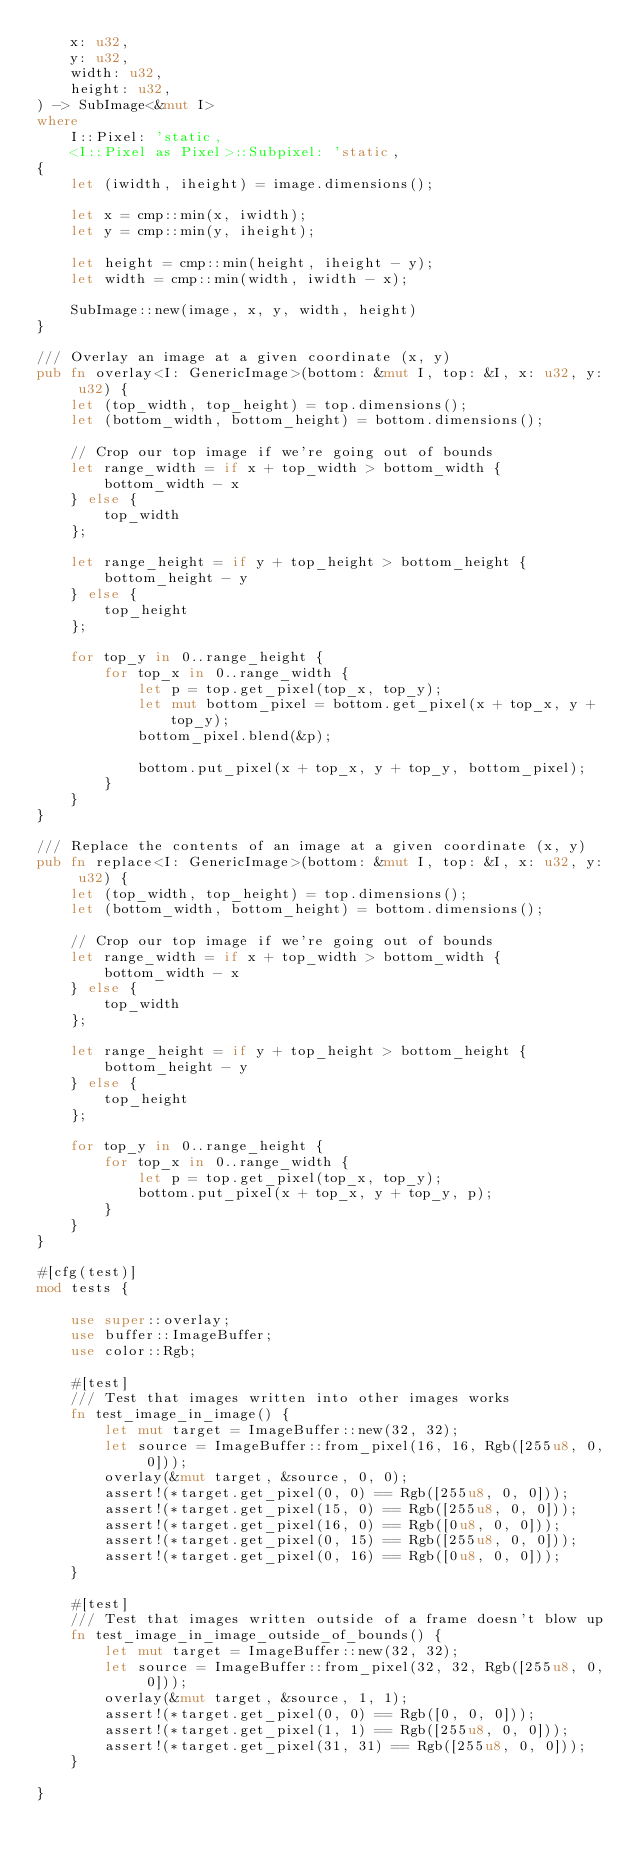<code> <loc_0><loc_0><loc_500><loc_500><_Rust_>    x: u32,
    y: u32,
    width: u32,
    height: u32,
) -> SubImage<&mut I>
where
    I::Pixel: 'static,
    <I::Pixel as Pixel>::Subpixel: 'static,
{
    let (iwidth, iheight) = image.dimensions();

    let x = cmp::min(x, iwidth);
    let y = cmp::min(y, iheight);

    let height = cmp::min(height, iheight - y);
    let width = cmp::min(width, iwidth - x);

    SubImage::new(image, x, y, width, height)
}

/// Overlay an image at a given coordinate (x, y)
pub fn overlay<I: GenericImage>(bottom: &mut I, top: &I, x: u32, y: u32) {
    let (top_width, top_height) = top.dimensions();
    let (bottom_width, bottom_height) = bottom.dimensions();

    // Crop our top image if we're going out of bounds
    let range_width = if x + top_width > bottom_width {
        bottom_width - x
    } else {
        top_width
    };

    let range_height = if y + top_height > bottom_height {
        bottom_height - y
    } else {
        top_height
    };

    for top_y in 0..range_height {
        for top_x in 0..range_width {
            let p = top.get_pixel(top_x, top_y);
            let mut bottom_pixel = bottom.get_pixel(x + top_x, y + top_y);
            bottom_pixel.blend(&p);

            bottom.put_pixel(x + top_x, y + top_y, bottom_pixel);
        }
    }
}

/// Replace the contents of an image at a given coordinate (x, y)
pub fn replace<I: GenericImage>(bottom: &mut I, top: &I, x: u32, y: u32) {
    let (top_width, top_height) = top.dimensions();
    let (bottom_width, bottom_height) = bottom.dimensions();

    // Crop our top image if we're going out of bounds
    let range_width = if x + top_width > bottom_width {
        bottom_width - x
    } else {
        top_width
    };

    let range_height = if y + top_height > bottom_height {
        bottom_height - y
    } else {
        top_height
    };

    for top_y in 0..range_height {
        for top_x in 0..range_width {
            let p = top.get_pixel(top_x, top_y);
            bottom.put_pixel(x + top_x, y + top_y, p);
        }
    }
}

#[cfg(test)]
mod tests {

    use super::overlay;
    use buffer::ImageBuffer;
    use color::Rgb;

    #[test]
    /// Test that images written into other images works
    fn test_image_in_image() {
        let mut target = ImageBuffer::new(32, 32);
        let source = ImageBuffer::from_pixel(16, 16, Rgb([255u8, 0, 0]));
        overlay(&mut target, &source, 0, 0);
        assert!(*target.get_pixel(0, 0) == Rgb([255u8, 0, 0]));
        assert!(*target.get_pixel(15, 0) == Rgb([255u8, 0, 0]));
        assert!(*target.get_pixel(16, 0) == Rgb([0u8, 0, 0]));
        assert!(*target.get_pixel(0, 15) == Rgb([255u8, 0, 0]));
        assert!(*target.get_pixel(0, 16) == Rgb([0u8, 0, 0]));
    }

    #[test]
    /// Test that images written outside of a frame doesn't blow up
    fn test_image_in_image_outside_of_bounds() {
        let mut target = ImageBuffer::new(32, 32);
        let source = ImageBuffer::from_pixel(32, 32, Rgb([255u8, 0, 0]));
        overlay(&mut target, &source, 1, 1);
        assert!(*target.get_pixel(0, 0) == Rgb([0, 0, 0]));
        assert!(*target.get_pixel(1, 1) == Rgb([255u8, 0, 0]));
        assert!(*target.get_pixel(31, 31) == Rgb([255u8, 0, 0]));
    }

}
</code> 